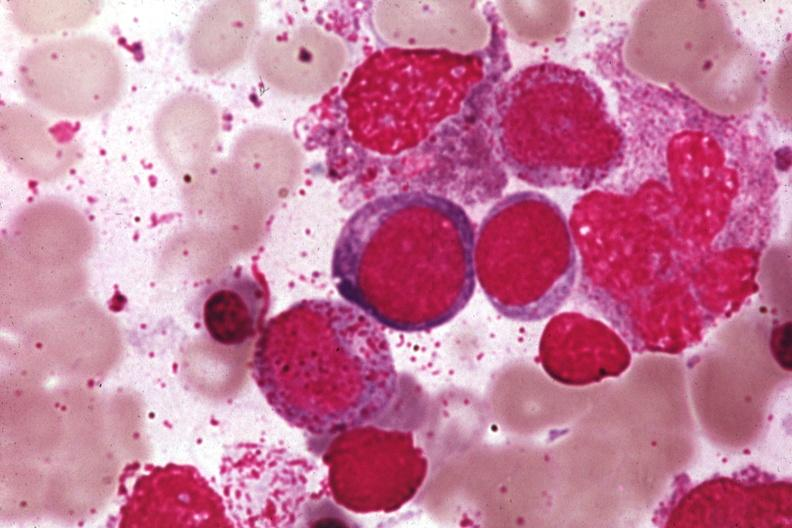s hematologic present?
Answer the question using a single word or phrase. Yes 